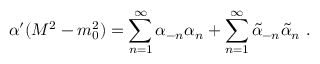<formula> <loc_0><loc_0><loc_500><loc_500>\alpha ^ { \prime } ( M ^ { 2 } - m _ { 0 } ^ { 2 } ) = \sum _ { n = 1 } ^ { \infty } \alpha _ { - n } \alpha _ { n } + \sum _ { n = 1 } ^ { \infty } \widetilde { \alpha } _ { - n } \widetilde { \alpha } _ { n } \ .</formula> 